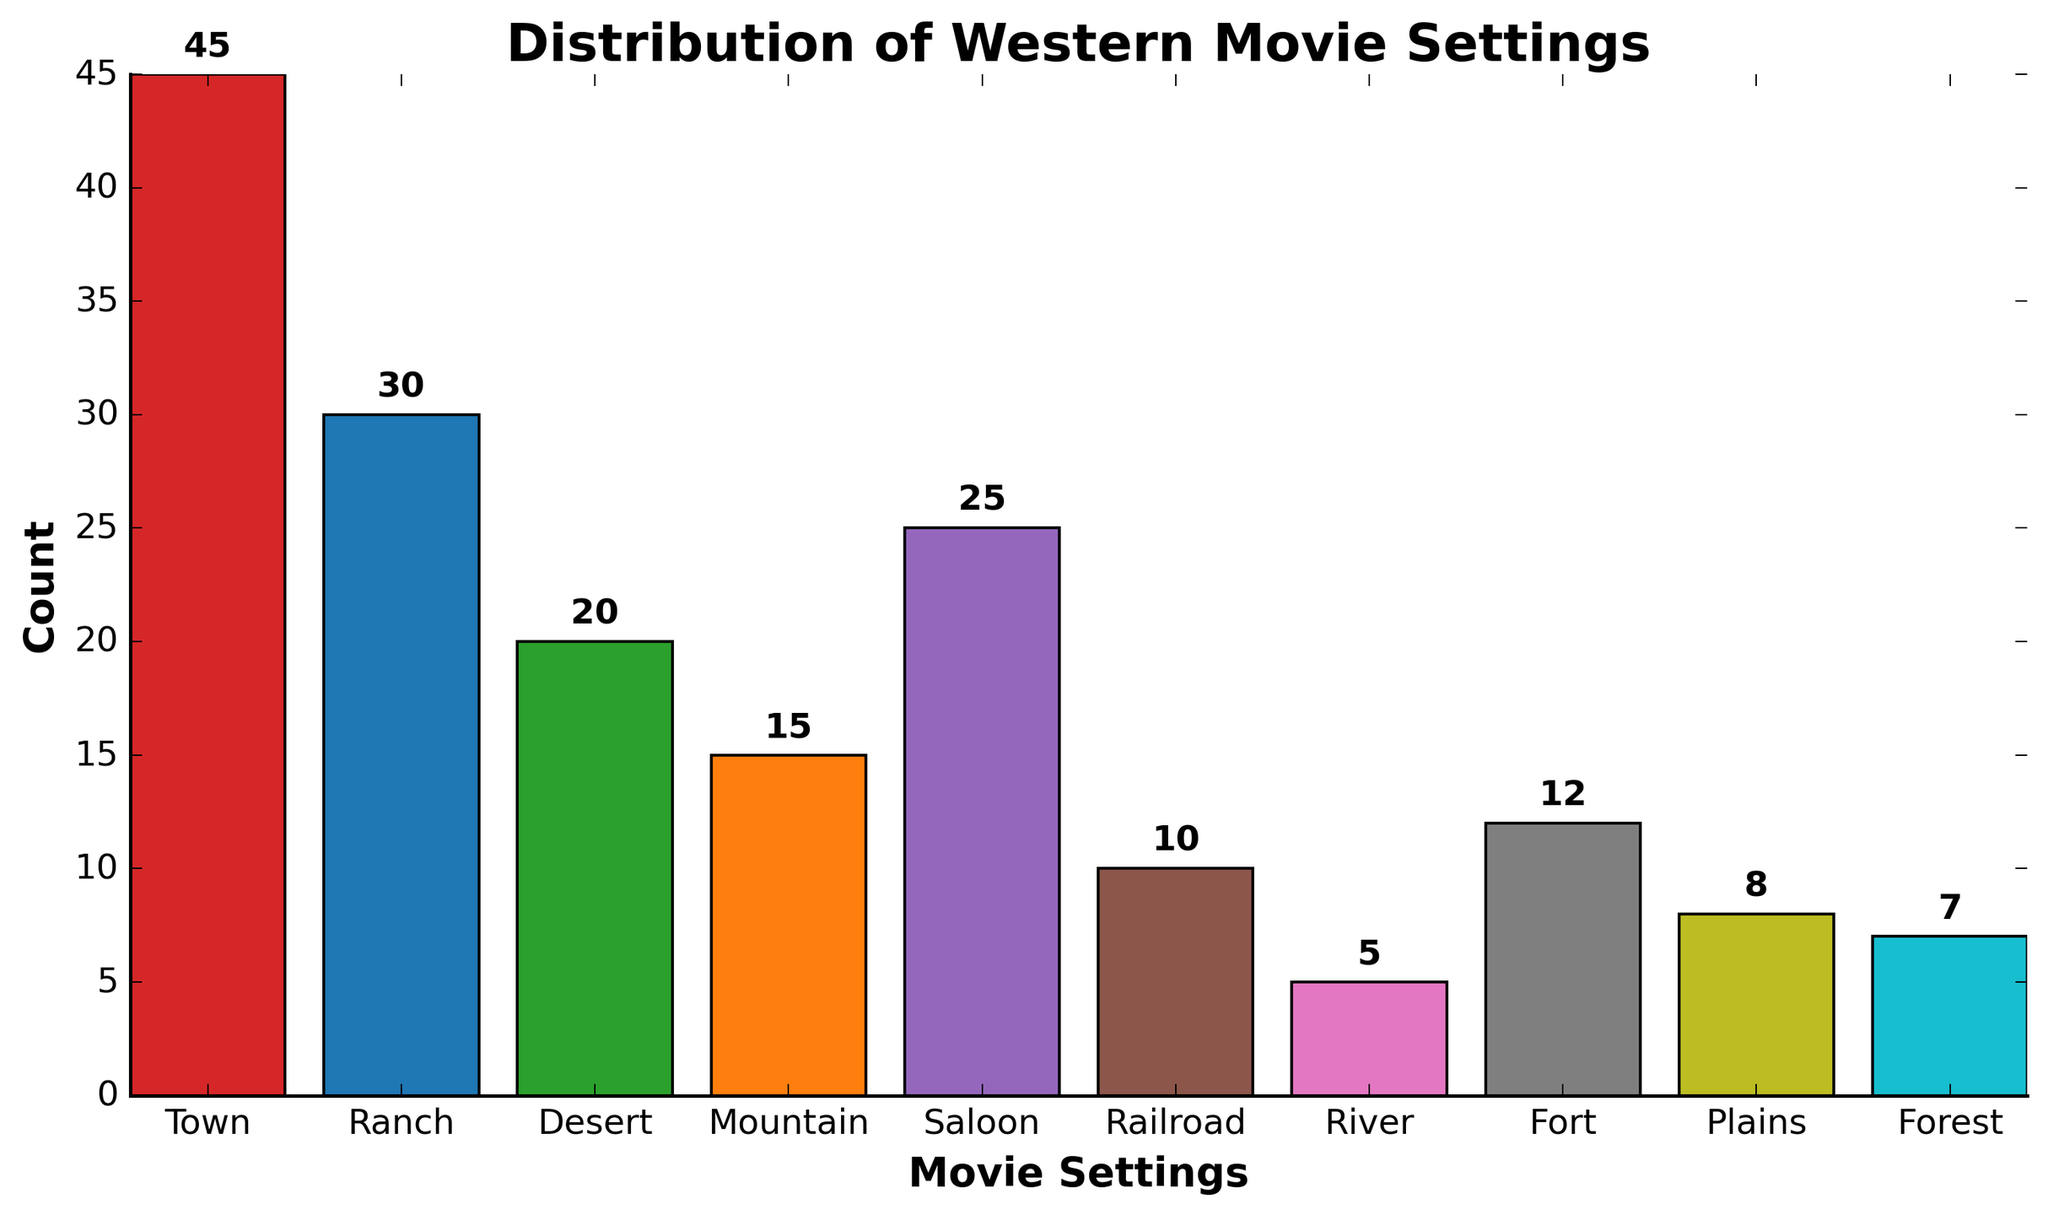Which setting has the highest count? The tallest bar represents the setting with the highest count. Town has the highest count with 45.
Answer: Town Which setting has the lowest count? The shortest bar represents the setting with the lowest count. River has the lowest count with 5.
Answer: River How many more movies were set in Town compared to Ranch? The count for Town is 45 and for Ranch is 30. The difference is 45 - 30 = 15.
Answer: 15 Is the number of movies set in Saloon greater than those set in Fort? Compare the heights of the bars: Saloon has 25, and Fort has 12. 25 is greater than 12.
Answer: Yes What's the total count of movies set in natural settings like Desert, Mountain, Plains, and Forest combined? Sum the counts for these settings: Desert (20) + Mountain (15) + Plains (8) + Forest (7) = 50.
Answer: 50 Which setting has a count closer to the median value among all settings? The data sorted in ascending order of counts is: River (5), Forest (7), Plains (8), Railroad (10), Fort (12), Mountain (15), Desert (20), Saloon (25), Ranch (30), Town (45). The median is between Fort (12) and Mountain (15), so Mountain (15) is closer.
Answer: Mountain How many settings have counts between 10 and 20 inclusive? Identify which counts fall in this range: Railroad (10), Fort (12), Mountain (15), and Desert (20). There are 4 settings.
Answer: 4 What's the average count for all the settings shown? Sum all counts: 45 + 30 + 20 + 15 + 25 + 10 + 5 + 12 + 8 + 7 = 177. There are 10 settings. Average is 177 / 10 = 17.7.
Answer: 17.7 Which setting represented with the second highest count? The second tallest bar represents the second highest count. Ranch has the second highest count with 30.
Answer: Ranch 